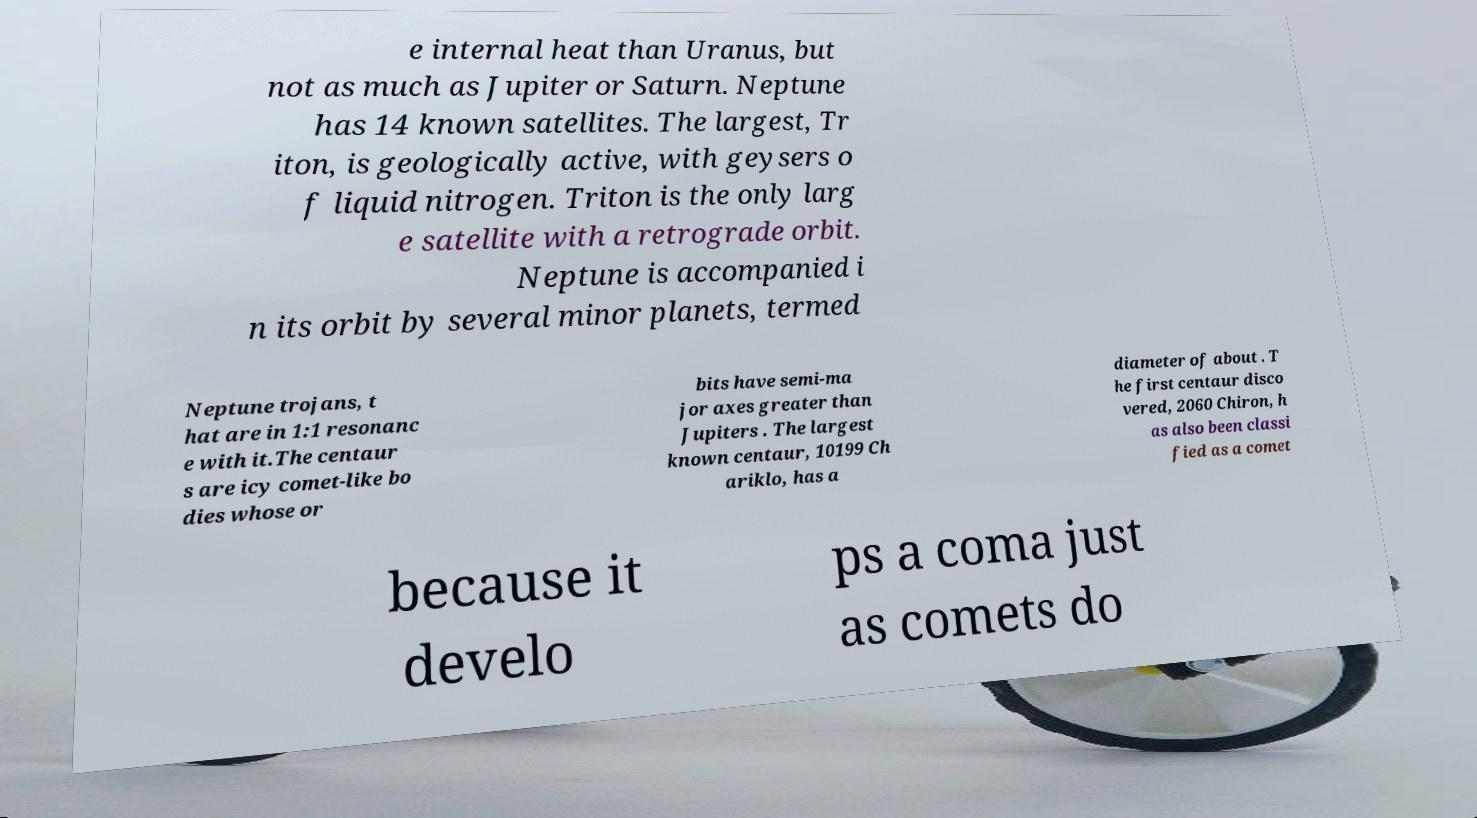There's text embedded in this image that I need extracted. Can you transcribe it verbatim? e internal heat than Uranus, but not as much as Jupiter or Saturn. Neptune has 14 known satellites. The largest, Tr iton, is geologically active, with geysers o f liquid nitrogen. Triton is the only larg e satellite with a retrograde orbit. Neptune is accompanied i n its orbit by several minor planets, termed Neptune trojans, t hat are in 1:1 resonanc e with it.The centaur s are icy comet-like bo dies whose or bits have semi-ma jor axes greater than Jupiters . The largest known centaur, 10199 Ch ariklo, has a diameter of about . T he first centaur disco vered, 2060 Chiron, h as also been classi fied as a comet because it develo ps a coma just as comets do 